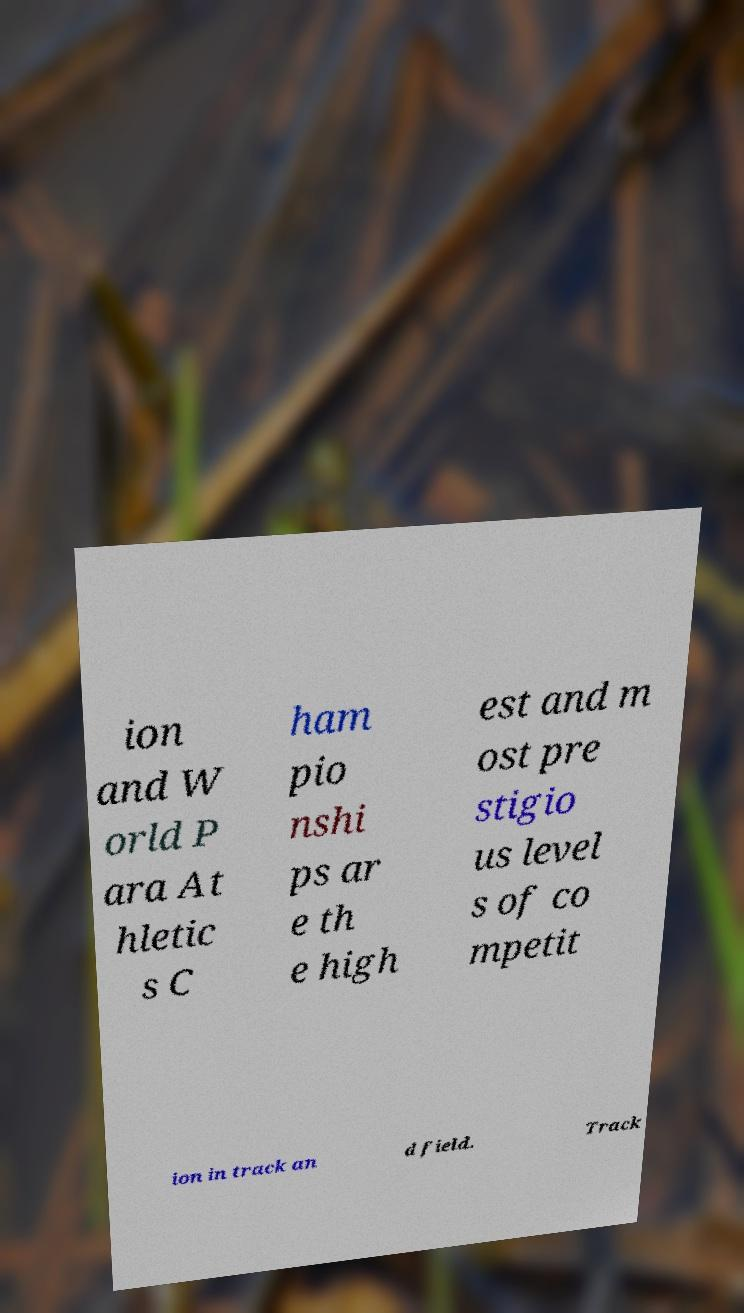Could you assist in decoding the text presented in this image and type it out clearly? ion and W orld P ara At hletic s C ham pio nshi ps ar e th e high est and m ost pre stigio us level s of co mpetit ion in track an d field. Track 